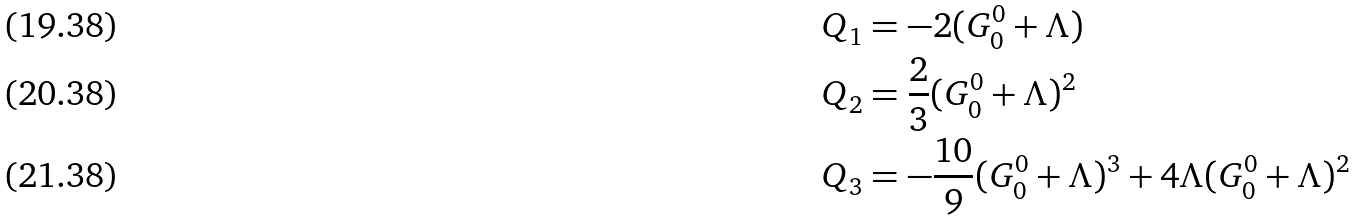Convert formula to latex. <formula><loc_0><loc_0><loc_500><loc_500>Q _ { 1 } & = - 2 ( G ^ { 0 } _ { 0 } + \Lambda ) \\ Q _ { 2 } & = \frac { 2 } { 3 } ( G ^ { 0 } _ { 0 } + \Lambda ) ^ { 2 } \\ Q _ { 3 } & = - \frac { 1 0 } { 9 } ( G ^ { 0 } _ { 0 } + \Lambda ) ^ { 3 } + 4 \Lambda ( G ^ { 0 } _ { 0 } + \Lambda ) ^ { 2 }</formula> 